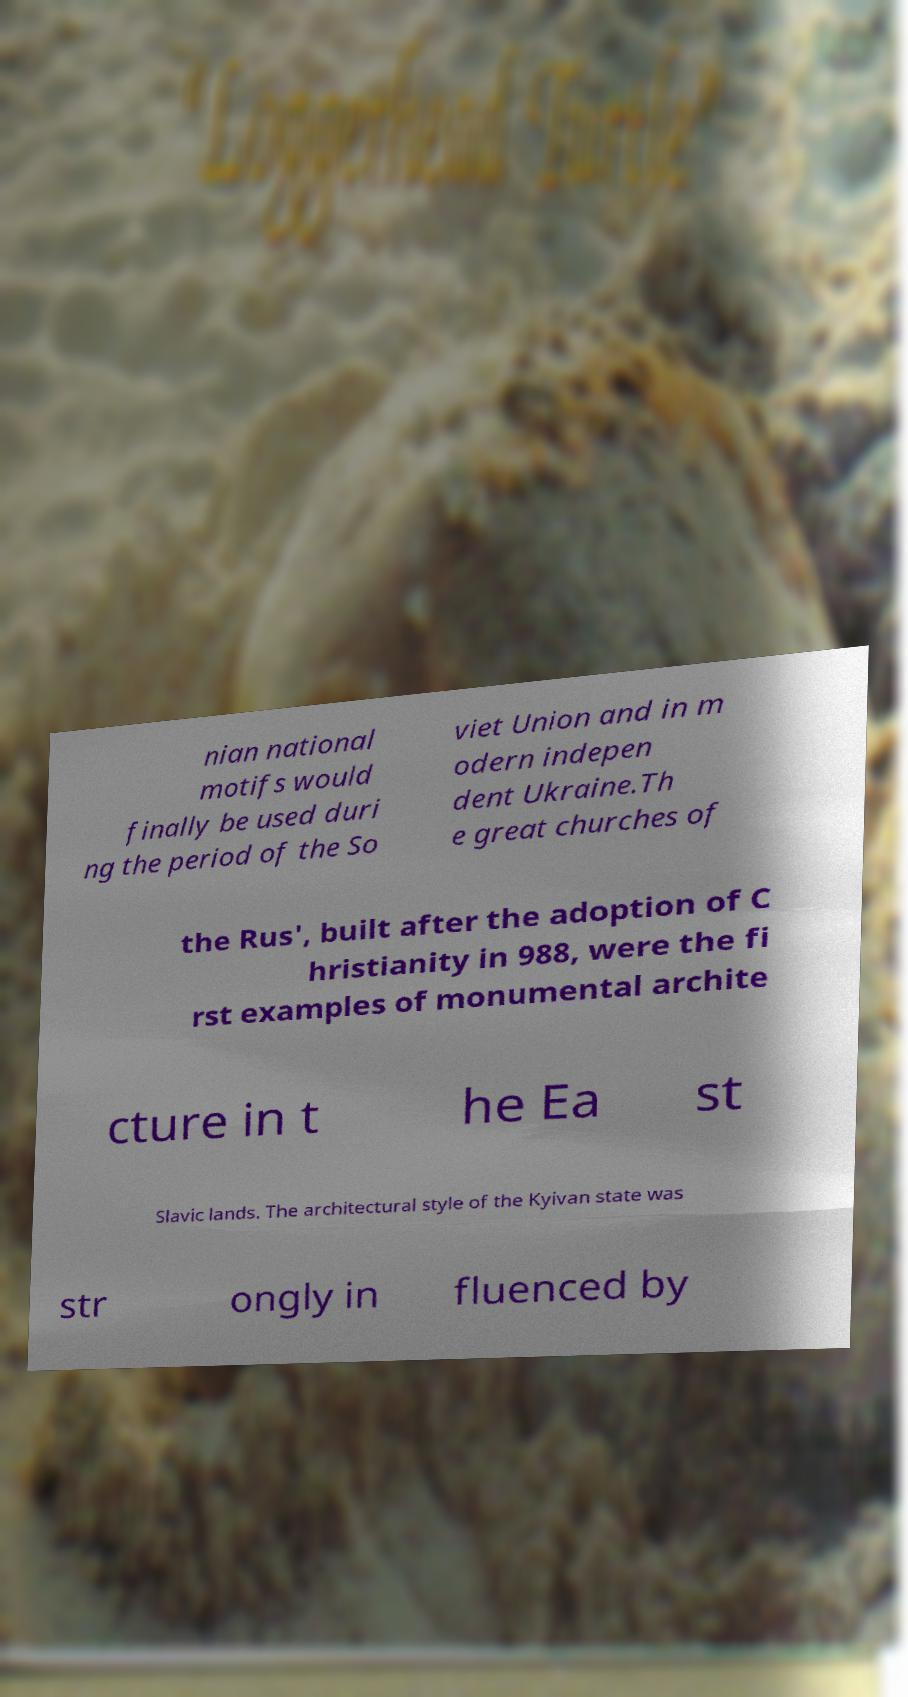Can you accurately transcribe the text from the provided image for me? nian national motifs would finally be used duri ng the period of the So viet Union and in m odern indepen dent Ukraine.Th e great churches of the Rus', built after the adoption of C hristianity in 988, were the fi rst examples of monumental archite cture in t he Ea st Slavic lands. The architectural style of the Kyivan state was str ongly in fluenced by 